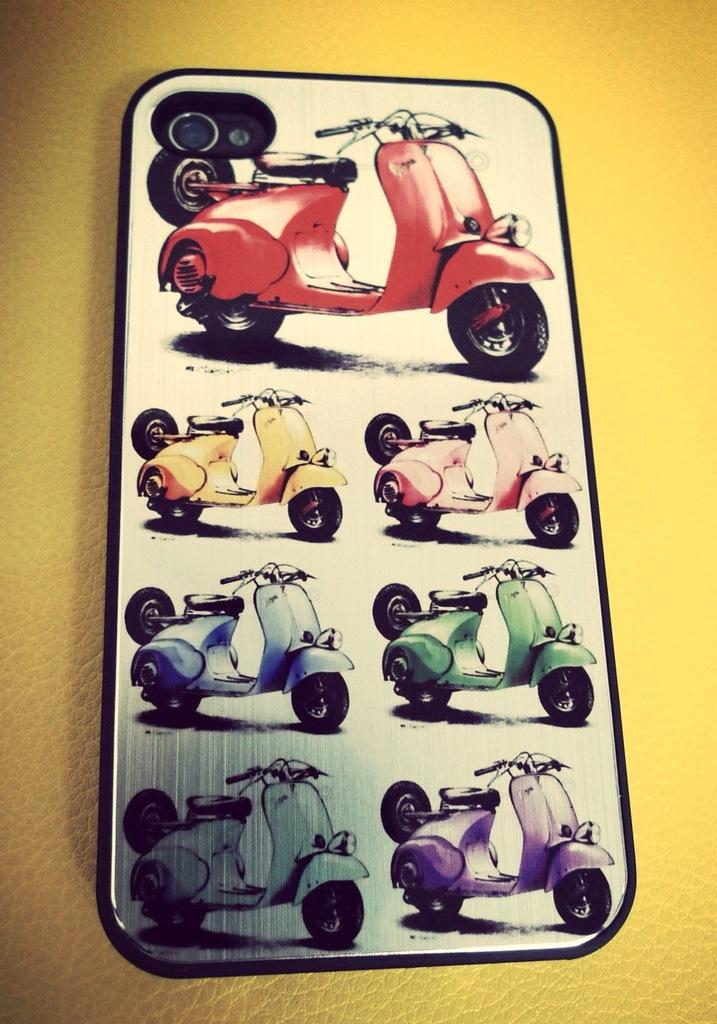What is the main subject of the picture? The main subject of the picture is a mobile phone back case. What type of images are on the back case? The back case has images of scooters. Can you describe the scooters on the back case? The scooters are in different colors. How many tails can be seen on the scooters in the image? There are no tails visible on the scooters in the image, as scooters do not have tails. What type of egg is featured in the image? There is no egg present in the image; it features a mobile phone back case with images of scooters. 